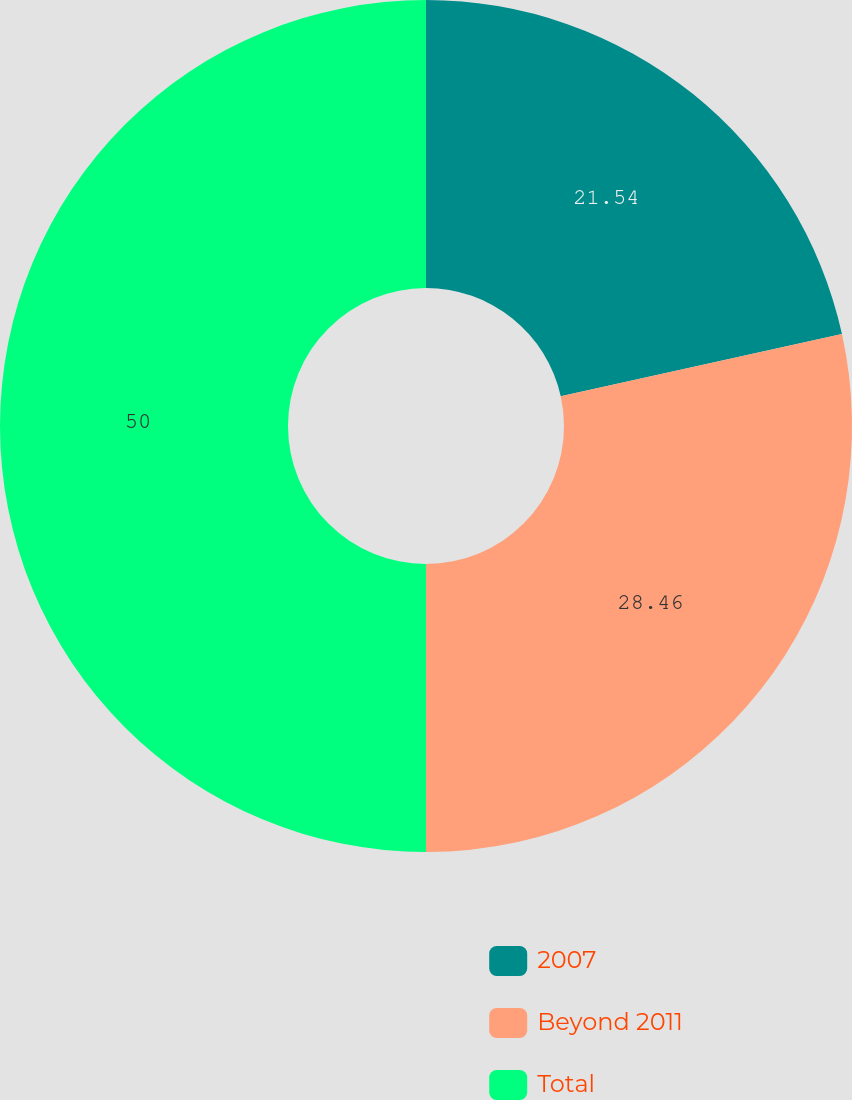Convert chart to OTSL. <chart><loc_0><loc_0><loc_500><loc_500><pie_chart><fcel>2007<fcel>Beyond 2011<fcel>Total<nl><fcel>21.54%<fcel>28.46%<fcel>50.0%<nl></chart> 